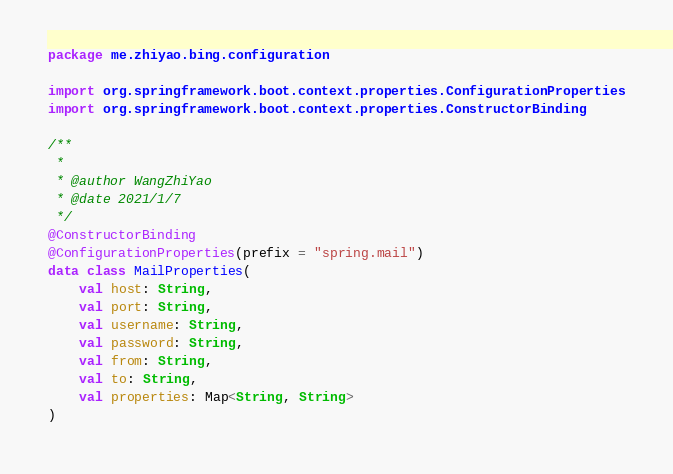<code> <loc_0><loc_0><loc_500><loc_500><_Kotlin_>package me.zhiyao.bing.configuration

import org.springframework.boot.context.properties.ConfigurationProperties
import org.springframework.boot.context.properties.ConstructorBinding

/**
 *
 * @author WangZhiYao
 * @date 2021/1/7
 */
@ConstructorBinding
@ConfigurationProperties(prefix = "spring.mail")
data class MailProperties(
    val host: String,
    val port: String,
    val username: String,
    val password: String,
    val from: String,
    val to: String,
    val properties: Map<String, String>
)</code> 